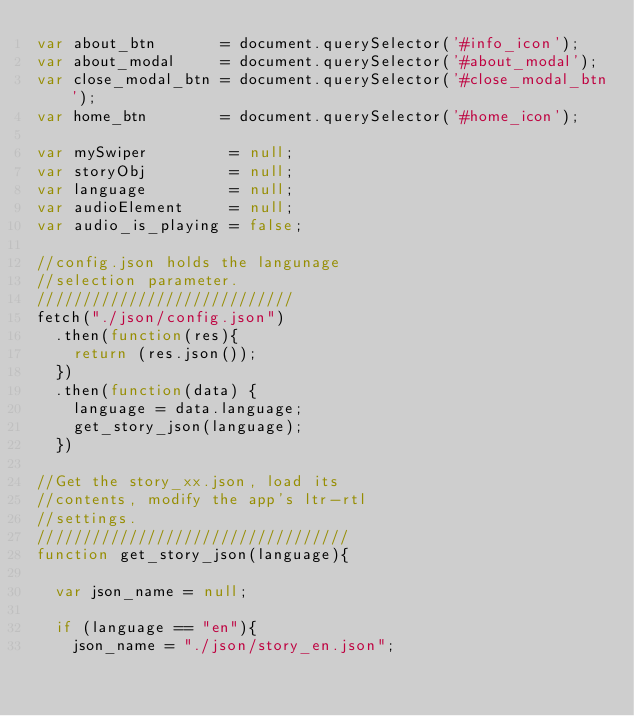Convert code to text. <code><loc_0><loc_0><loc_500><loc_500><_JavaScript_>var about_btn       = document.querySelector('#info_icon');
var about_modal     = document.querySelector('#about_modal');
var close_modal_btn = document.querySelector('#close_modal_btn');
var home_btn        = document.querySelector('#home_icon');

var mySwiper         = null;
var storyObj         = null;
var language         = null;
var audioElement     = null;
var audio_is_playing = false;

//config.json holds the langunage
//selection parameter.
////////////////////////////
fetch("./json/config.json")
  .then(function(res){
    return (res.json());
  })
  .then(function(data) {
    language = data.language;
    get_story_json(language);  
  })

//Get the story_xx.json, load its 
//contents, modify the app's ltr-rtl
//settings.
//////////////////////////////////
function get_story_json(language){

  var json_name = null;
  
  if (language == "en"){
    json_name = "./json/story_en.json";</code> 